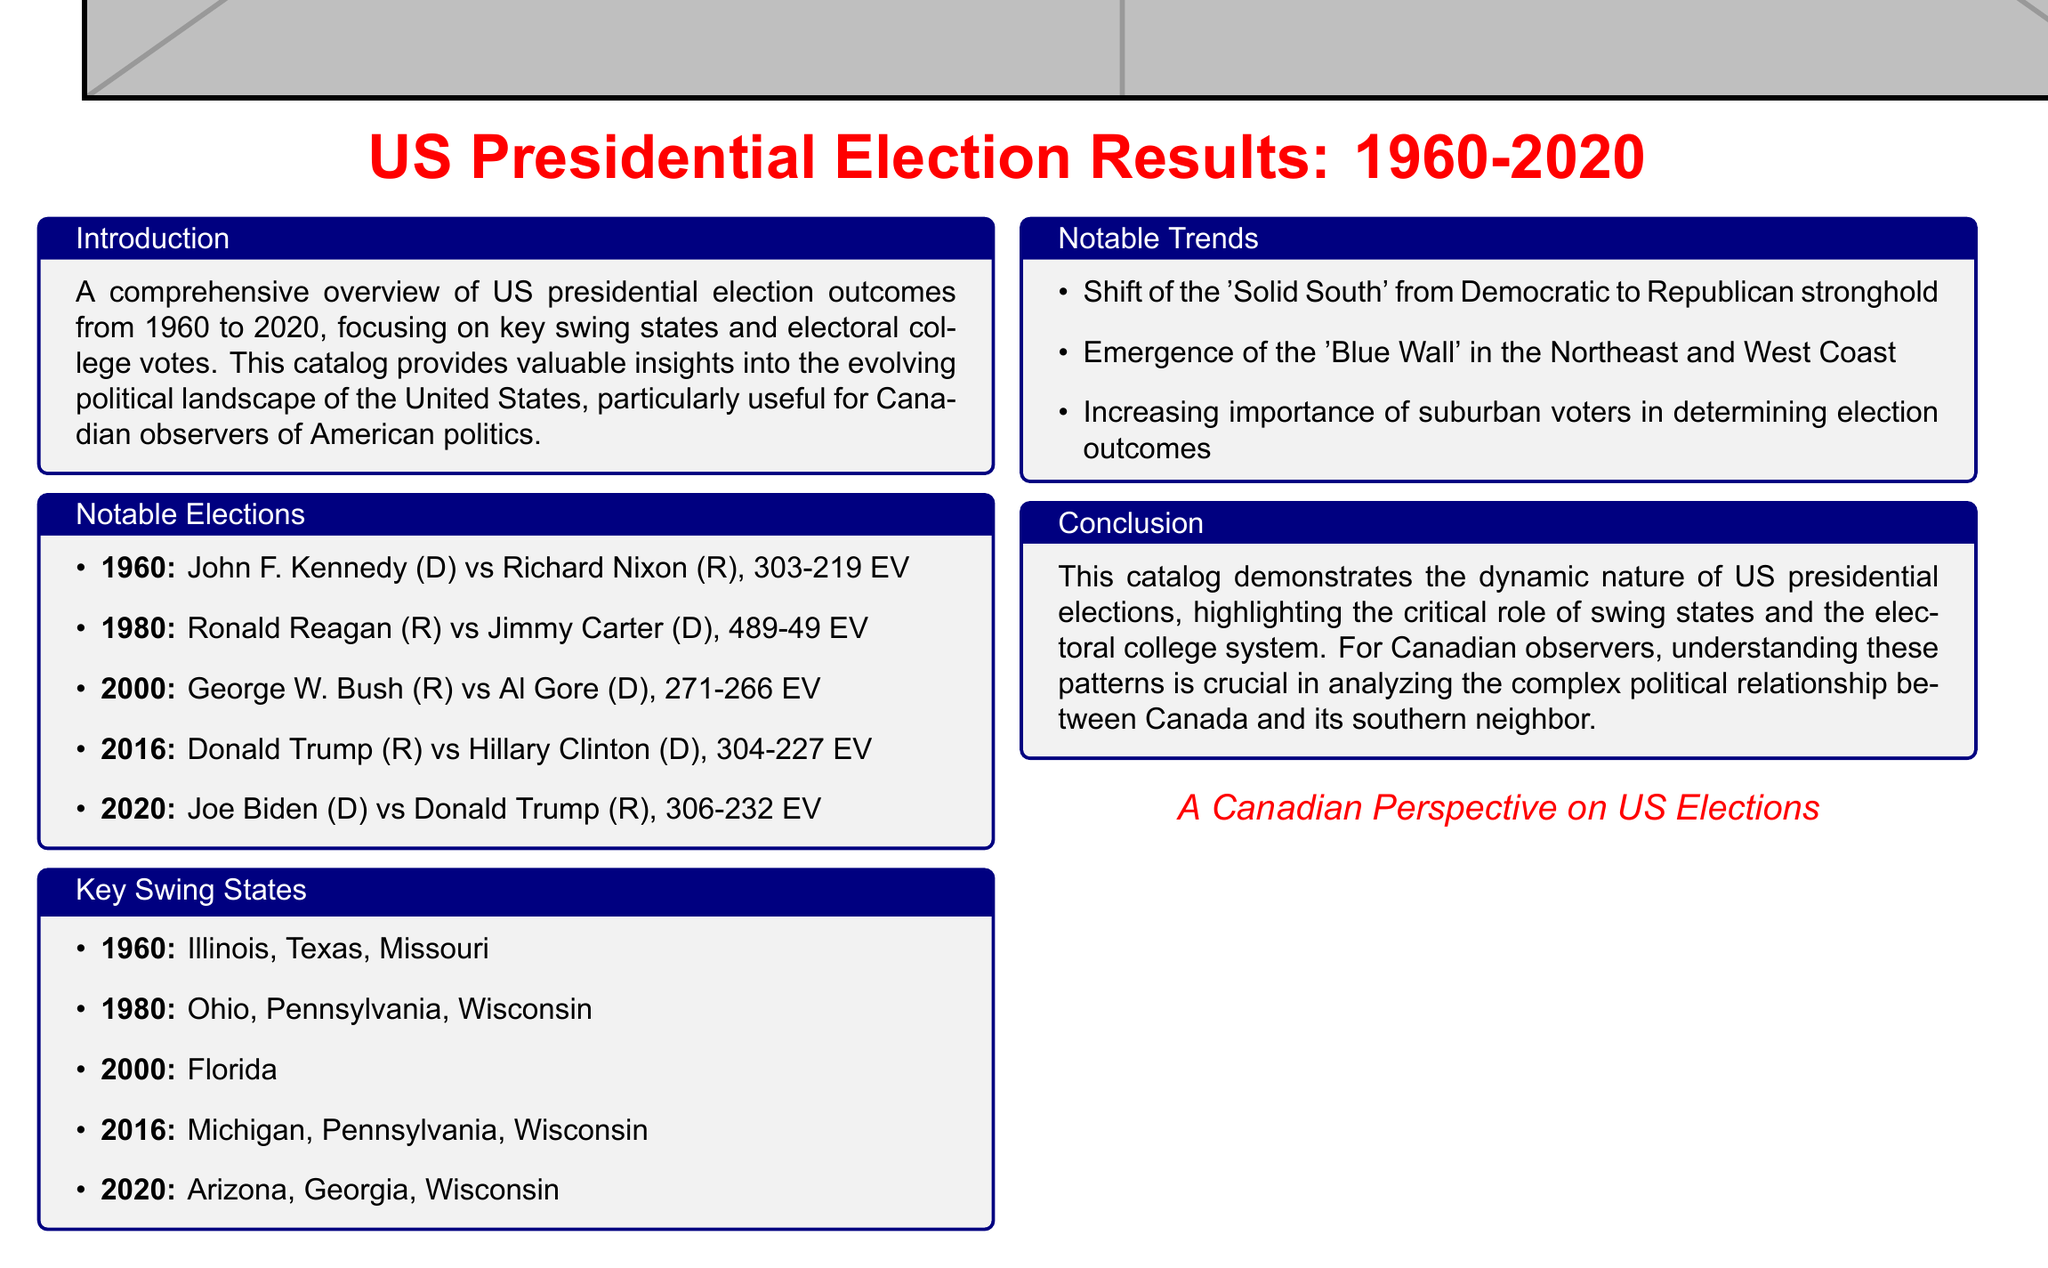what was the electoral vote count in 1960? The document specifies that in 1960, John F. Kennedy (D) vs Richard Nixon (R) resulted in a total electoral vote count of 303-219.
Answer: 303-219 what were the key swing states in 2020? According to the document, the key swing states identified for the 2020 election were Arizona, Georgia, and Wisconsin.
Answer: Arizona, Georgia, Wisconsin who won the 1980 presidential election? The document lists the candidates Ronald Reagan (R) and Jimmy Carter (D), indicating that Ronald Reagan won the election.
Answer: Ronald Reagan what notable trend is mentioned regarding suburban voters? The document states that the increasing importance of suburban voters is a notable trend in US presidential elections.
Answer: Increasing importance how many electoral votes did Joe Biden receive in 2020? The document provides that Joe Biden received 306 electoral votes in the 2020 election against Donald Trump.
Answer: 306 which election was described as having the 'Solid South' shift? The document notes the notable trend of the shift of the 'Solid South' from a Democratic to a Republican stronghold.
Answer: Shift of 'Solid South' what year did George W. Bush vs Al Gore occur? The document lists the year of the presidential election between George W. Bush (R) and Al Gore (D) as 2000.
Answer: 2000 which three key swing states were listed for the 2016 election? The document indicates the key swing states for the 2016 election were Michigan, Pennsylvania, and Wisconsin.
Answer: Michigan, Pennsylvania, Wisconsin what is the title of the catalog? The document highlights the title as "US Presidential Election Results: 1960-2020".
Answer: US Presidential Election Results: 1960-2020 